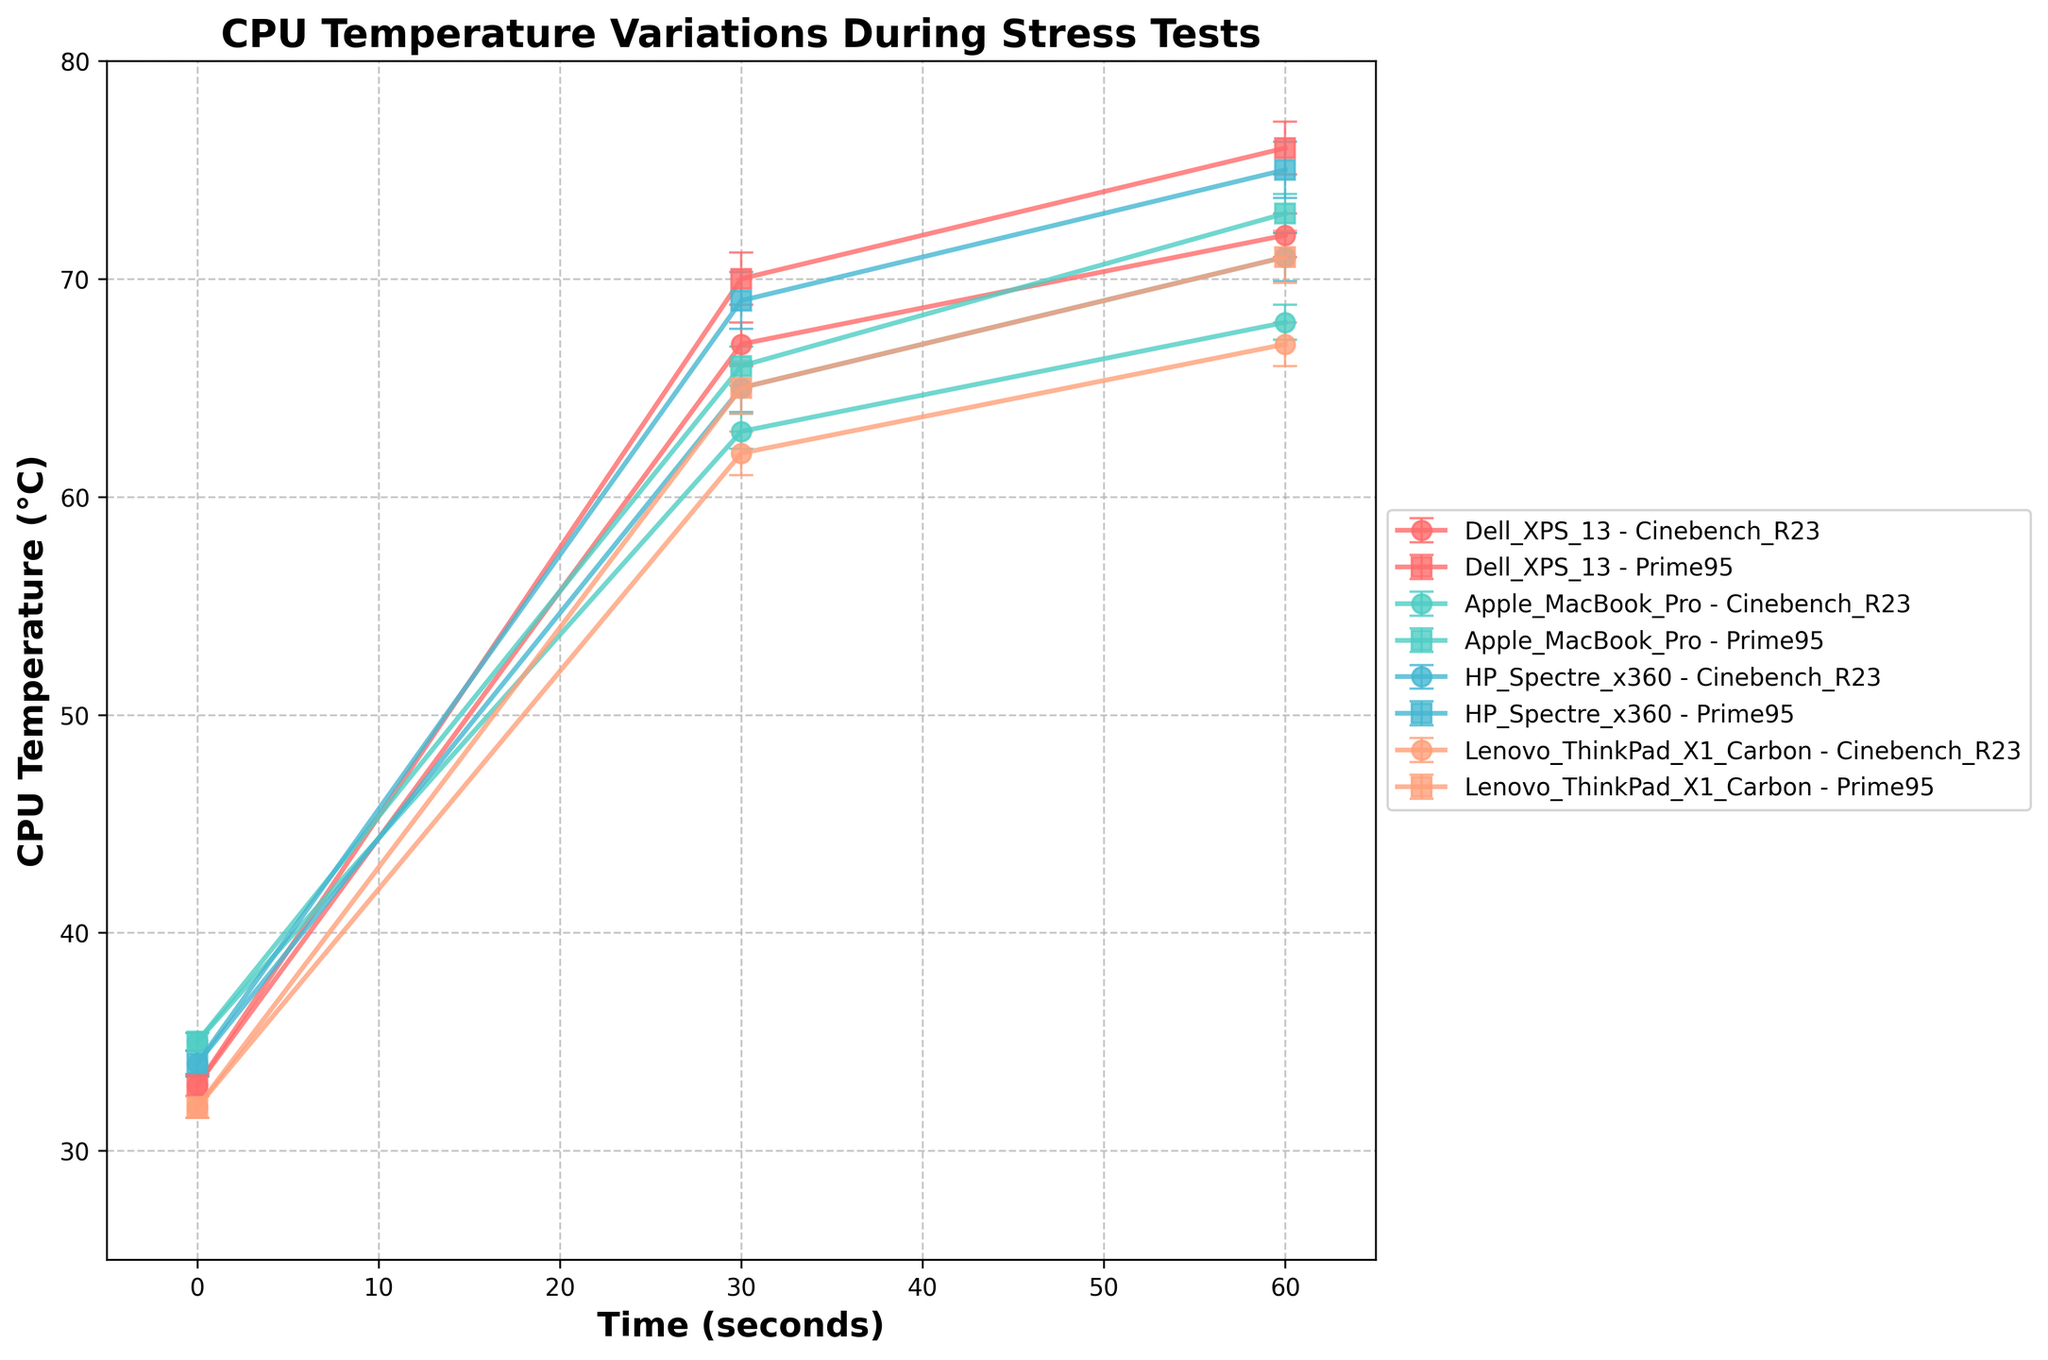What's the title of the figure? The title of the figure is displayed prominently at the top. It provides an overview of what the figure represents.
Answer: CPU Temperature Variations During Stress Tests What are the labels for the x-axis and y-axis? The axis labels are located along the respective axes and describe what each axis represents.
Answer: Time (seconds) and CPU Temperature (°C) How many different computer models are included in the figure? By examining the legend on the right-hand side, we can count the number of distinct computer models listed.
Answer: Four Which computer model has the highest peak temperature during the Cinebench R23 test? To determine this, compare the maximum temperature values for each model during the Cinebench R23 test.
Answer: Dell XPS 13 At the 60-second mark, which computer model showed the lowest CPU temperature during the Prime95 test? Identify the temperature values for all models at the 60-second mark during the Prime95 test and find the minimum.
Answer: Lenovo ThinkPad X1 Carbon What is the overall trend in CPU temperature for the Dell XPS 13 during the Cinebench R23 test? The trend can be seen by looking at how the temperature values change over time for the Dell XPS 13 during the Cinebench R23 test.
Answer: Increasing Between the 30-second and 60-second marks, which computer model exhibited the largest change in CPU temperature during the Prime95 test? Calculate the difference in CPU temperature between these time points for all models, then determine the largest change.
Answer: HP Spectre x360 What is the approximate range of the error bars for the Apple MacBook Pro at the 30-second mark during the Prime95 test? The range of the error bars can be found by noting the size of the error values at this specific point.
Answer: ±0.9°C During the Cinebench R23 test, which computer model has the most consistent (least varying) CPU temperature? To determine consistency, compare the differences in temperature values across the time points for each model.
Answer: Lenovo ThinkPad X1 Carbon 